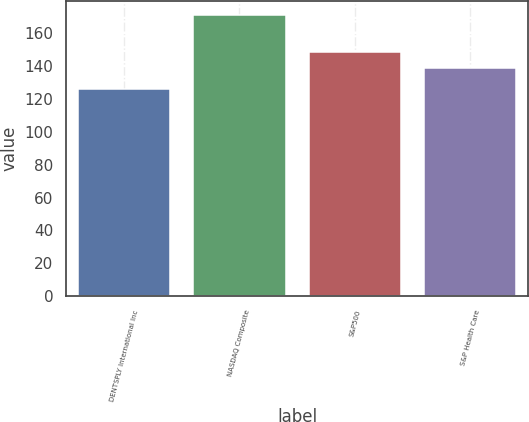Convert chart to OTSL. <chart><loc_0><loc_0><loc_500><loc_500><bar_chart><fcel>DENTSPLY International Inc<fcel>NASDAQ Composite<fcel>S&P500<fcel>S&P Health Care<nl><fcel>126.22<fcel>171.3<fcel>148.59<fcel>138.85<nl></chart> 